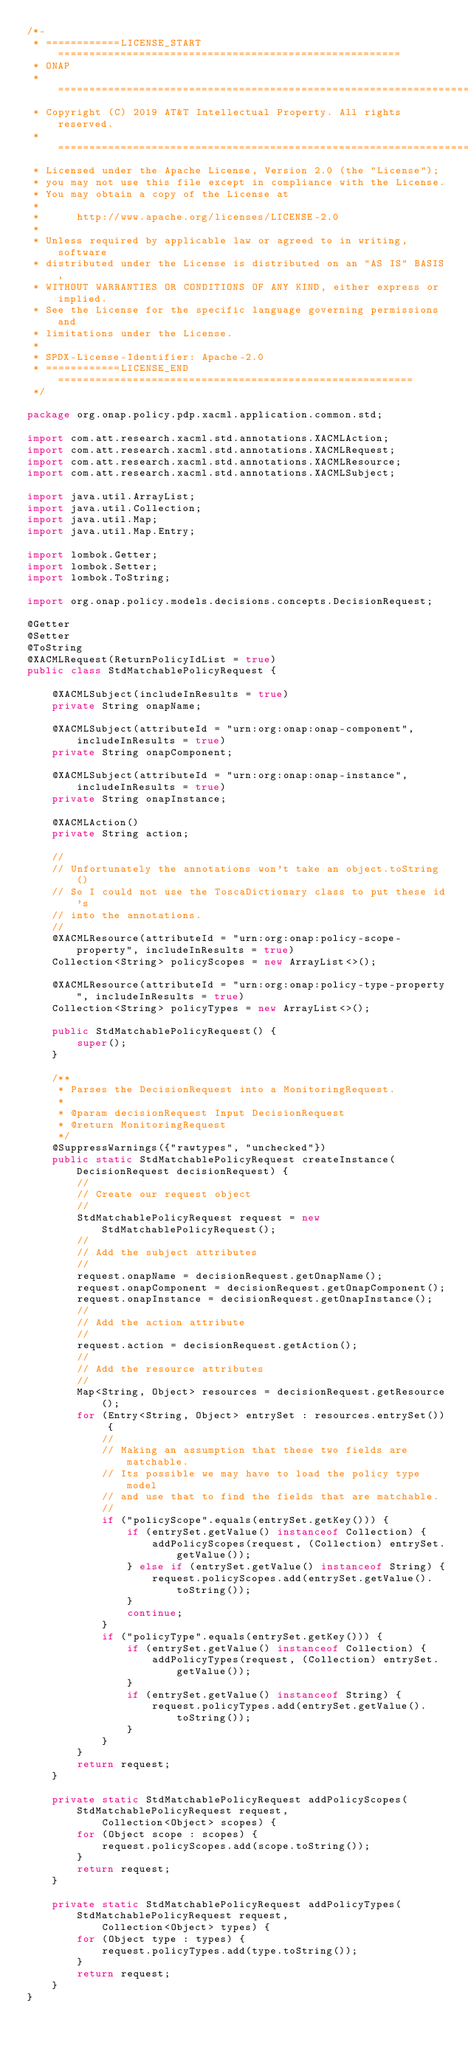Convert code to text. <code><loc_0><loc_0><loc_500><loc_500><_Java_>/*-
 * ============LICENSE_START=======================================================
 * ONAP
 * ================================================================================
 * Copyright (C) 2019 AT&T Intellectual Property. All rights reserved.
 * ================================================================================
 * Licensed under the Apache License, Version 2.0 (the "License");
 * you may not use this file except in compliance with the License.
 * You may obtain a copy of the License at
 *
 *      http://www.apache.org/licenses/LICENSE-2.0
 *
 * Unless required by applicable law or agreed to in writing, software
 * distributed under the License is distributed on an "AS IS" BASIS,
 * WITHOUT WARRANTIES OR CONDITIONS OF ANY KIND, either express or implied.
 * See the License for the specific language governing permissions and
 * limitations under the License.
 *
 * SPDX-License-Identifier: Apache-2.0
 * ============LICENSE_END=========================================================
 */

package org.onap.policy.pdp.xacml.application.common.std;

import com.att.research.xacml.std.annotations.XACMLAction;
import com.att.research.xacml.std.annotations.XACMLRequest;
import com.att.research.xacml.std.annotations.XACMLResource;
import com.att.research.xacml.std.annotations.XACMLSubject;

import java.util.ArrayList;
import java.util.Collection;
import java.util.Map;
import java.util.Map.Entry;

import lombok.Getter;
import lombok.Setter;
import lombok.ToString;

import org.onap.policy.models.decisions.concepts.DecisionRequest;

@Getter
@Setter
@ToString
@XACMLRequest(ReturnPolicyIdList = true)
public class StdMatchablePolicyRequest {

    @XACMLSubject(includeInResults = true)
    private String onapName;

    @XACMLSubject(attributeId = "urn:org:onap:onap-component", includeInResults = true)
    private String onapComponent;

    @XACMLSubject(attributeId = "urn:org:onap:onap-instance",  includeInResults = true)
    private String onapInstance;

    @XACMLAction()
    private String action;

    //
    // Unfortunately the annotations won't take an object.toString()
    // So I could not use the ToscaDictionary class to put these id's
    // into the annotations.
    //
    @XACMLResource(attributeId = "urn:org:onap:policy-scope-property", includeInResults = true)
    Collection<String> policyScopes = new ArrayList<>();

    @XACMLResource(attributeId = "urn:org:onap:policy-type-property", includeInResults = true)
    Collection<String> policyTypes = new ArrayList<>();

    public StdMatchablePolicyRequest() {
        super();
    }

    /**
     * Parses the DecisionRequest into a MonitoringRequest.
     *
     * @param decisionRequest Input DecisionRequest
     * @return MonitoringRequest
     */
    @SuppressWarnings({"rawtypes", "unchecked"})
    public static StdMatchablePolicyRequest createInstance(DecisionRequest decisionRequest) {
        //
        // Create our request object
        //
        StdMatchablePolicyRequest request = new StdMatchablePolicyRequest();
        //
        // Add the subject attributes
        //
        request.onapName = decisionRequest.getOnapName();
        request.onapComponent = decisionRequest.getOnapComponent();
        request.onapInstance = decisionRequest.getOnapInstance();
        //
        // Add the action attribute
        //
        request.action = decisionRequest.getAction();
        //
        // Add the resource attributes
        //
        Map<String, Object> resources = decisionRequest.getResource();
        for (Entry<String, Object> entrySet : resources.entrySet()) {
            //
            // Making an assumption that these two fields are matchable.
            // Its possible we may have to load the policy type model
            // and use that to find the fields that are matchable.
            //
            if ("policyScope".equals(entrySet.getKey())) {
                if (entrySet.getValue() instanceof Collection) {
                    addPolicyScopes(request, (Collection) entrySet.getValue());
                } else if (entrySet.getValue() instanceof String) {
                    request.policyScopes.add(entrySet.getValue().toString());
                }
                continue;
            }
            if ("policyType".equals(entrySet.getKey())) {
                if (entrySet.getValue() instanceof Collection) {
                    addPolicyTypes(request, (Collection) entrySet.getValue());
                }
                if (entrySet.getValue() instanceof String) {
                    request.policyTypes.add(entrySet.getValue().toString());
                }
            }
        }
        return request;
    }

    private static StdMatchablePolicyRequest addPolicyScopes(StdMatchablePolicyRequest request,
            Collection<Object> scopes) {
        for (Object scope : scopes) {
            request.policyScopes.add(scope.toString());
        }
        return request;
    }

    private static StdMatchablePolicyRequest addPolicyTypes(StdMatchablePolicyRequest request,
            Collection<Object> types) {
        for (Object type : types) {
            request.policyTypes.add(type.toString());
        }
        return request;
    }
}
</code> 